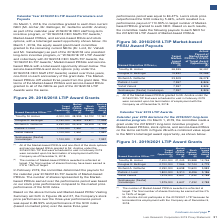According to Lam Research Corporation's financial document, What did the committee grant Mr Bettinger? Based on the financial document, the answer is a one-time service-based restricted stock unit (RSU) award with a nominal value of $8,000,000 and a four-year vesting schedule. Also, What did the independent members of the Board grant Mr Archer on December 6, 2018? The document shows two values: a $5,000,000 equity award consisting of 50% service-based RSUs and 50% stock options with a four-year vesting schedule. Also, Why did Mr Anstice not participate in the 2019/2021 LTIP? he terminated his employment with the Company as of December 5, 2018. The document states: "did not participate in the 2019/2021 LTIP because he terminated his employment with the Company as of December 5, 2018...." Additionally, Which named executive officer has the highest Service-based RSUs Award? According to the financial document, Timothy M. Archer. The relevant text states: "Timothy M. Archer 7,200,000 21,243 33,988 12,746..." Additionally, Which named executive officer has the highest Stock Options Award? According to the financial document, Timothy M. Archer. The relevant text states: "Timothy M. Archer 7,200,000 21,243 33,988 12,746..." Additionally, Which named executive officer has the highest Target Award Opportunity? According to the financial document, Timothy M. Archer. The relevant text states: "Timothy M. Archer 7,200,000 21,243 33,988 12,746..." 